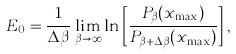<formula> <loc_0><loc_0><loc_500><loc_500>E _ { 0 } = \frac { 1 } { \Delta \beta } \lim _ { \beta \rightarrow \infty } \ln \left [ \frac { P _ { \beta } ( x _ { \max } ) } { P _ { \beta + \Delta \beta } ( x _ { \max } ) } \right ] ,</formula> 